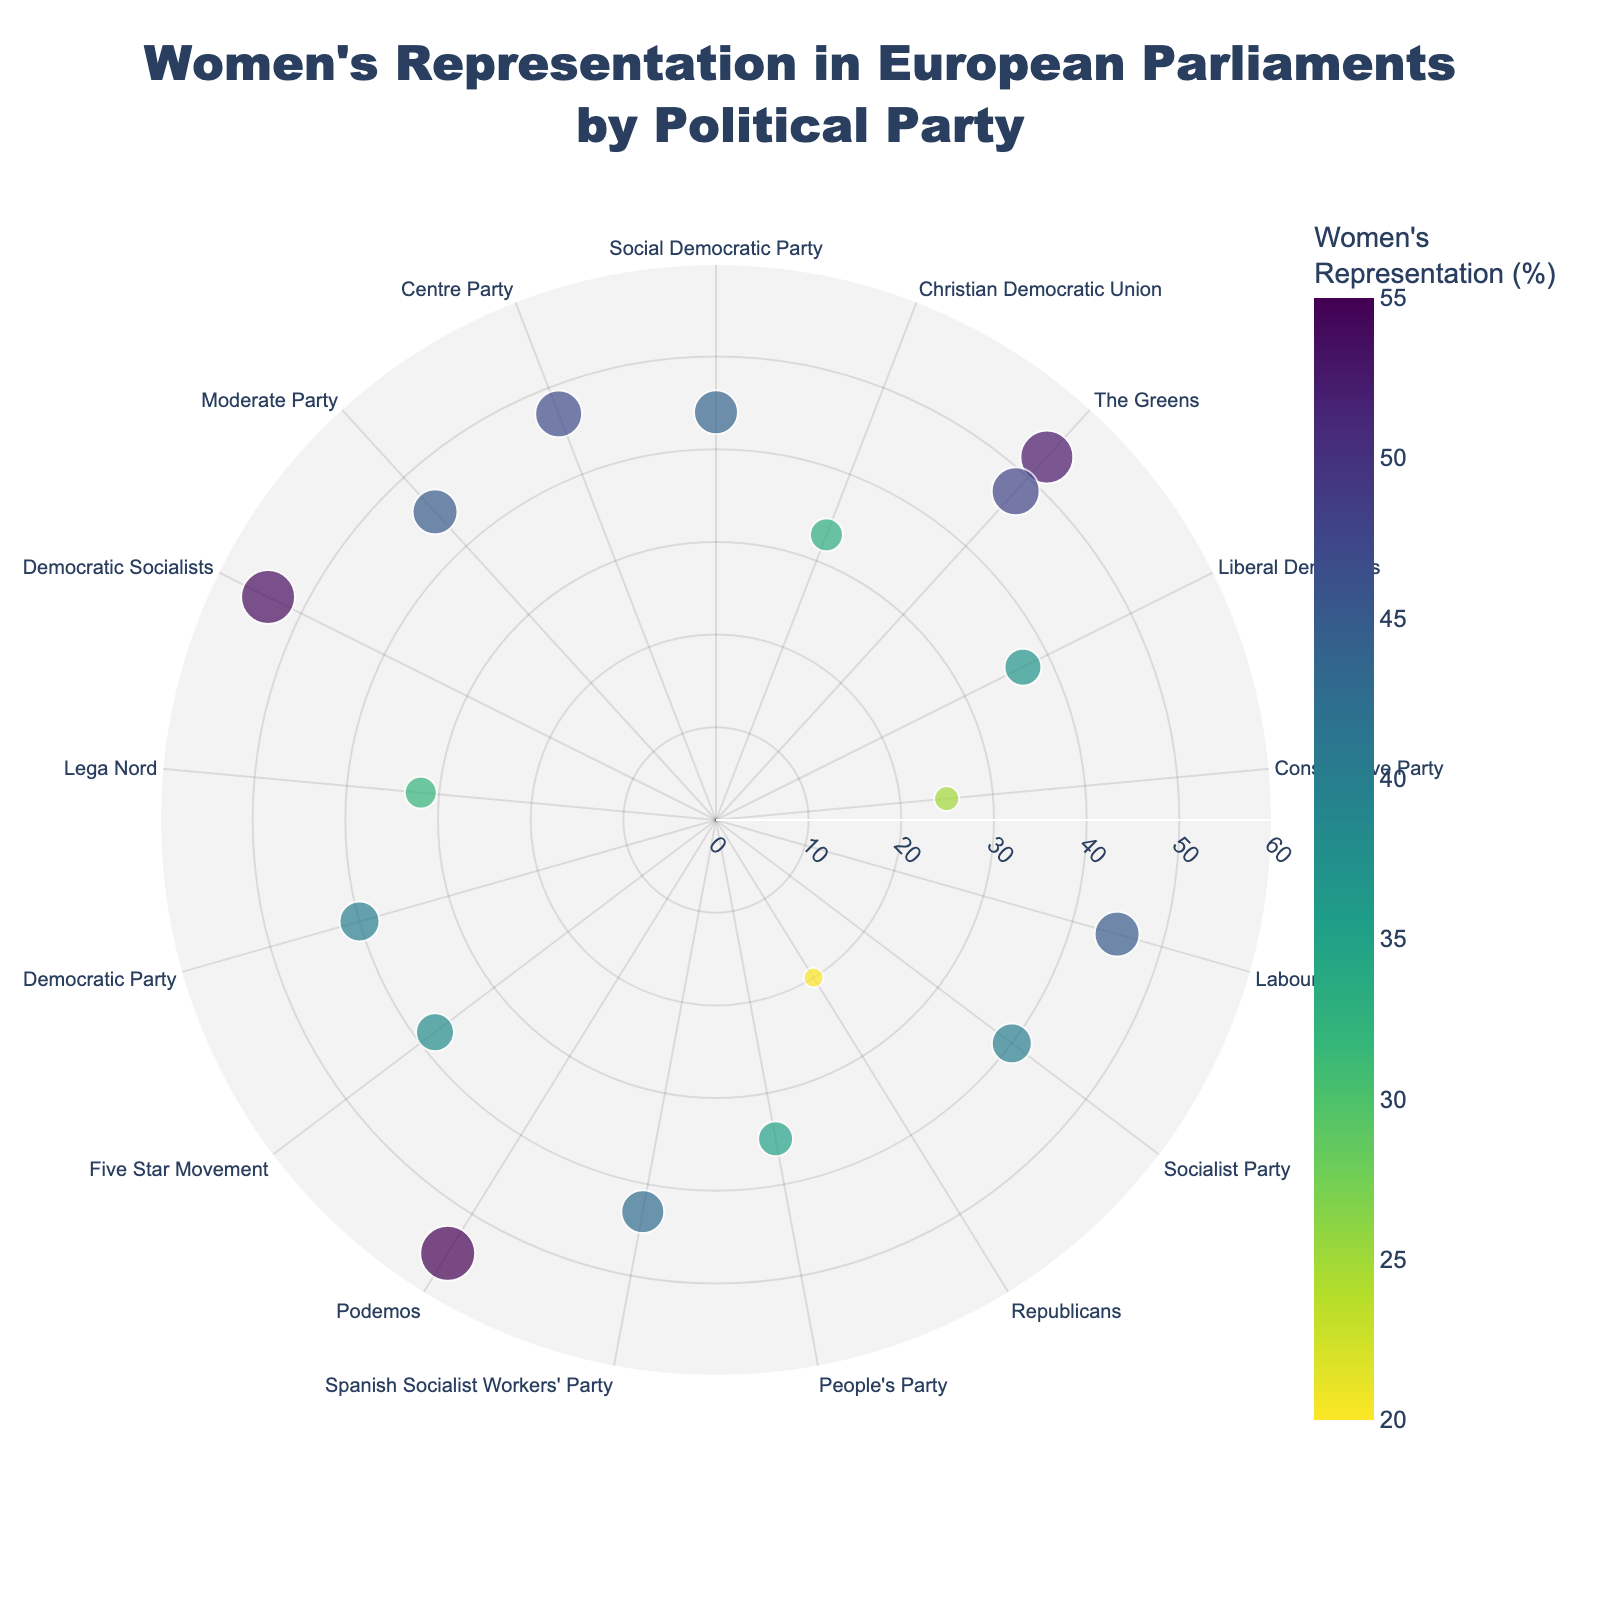What is the political party with the highest percentage of women's representation in Germany? The plot shows various political parties with labeled percentages for women's representation. By looking at the German parties, we see that The Greens have the highest value at 53%.
Answer: The Greens Which political party in the United Kingdom has the lowest percentage of women's representation? By examining the political parties from the United Kingdom on the plot, the Conservative Party shows the lowest percentage at 25%.
Answer: Conservative Party How does the women's representation in the Democratic Socialists (Sweden) compare to Lega Nord (Italy)? The plot indicates that the Democratic Socialists in Sweden have a percentage of 54% while Lega Nord in Italy has 32%. Therefore, the Democratic Socialists have a higher percentage of women's representation than Lega Nord.
Answer: Higher What is the approximate average percentage of women's representation among the political parties in France? The percentages for France are 48% (The Greens), 40% (Socialist Party), and 20% (Republicans). Summing these gives 108%, and dividing by the three parties, the average is approximately 36%.
Answer: 36% Which political party has a nearly equal percentage of women's representation to the Labour Party in the United Kingdom? The Labour Party in the United Kingdom has 45% women's representation. Checking other parties, the Moderate Party in Sweden also has 45%, making it roughly equal.
Answer: Moderate Party Which country has the highest average percentage of women's representation across its political parties? First, calculate each country's average:
  - Germany: (44+33+53)/3 = 43.33%
  - United Kingdom: (37+25+45)/3 = 35.67%
  - France: (48+40+20)/3 = 36%
  - Spain: (35+43+55)/3 = 44.33%
  - Italy: (38+40+32)/3 = 36.67%
  - Sweden: (54+45+47)/3 = 48.67%
  Sweden has the highest average with 48.67%.
Answer: Sweden Examine the radial distance in the polar chart. Which party lies closest to the outermost ring? The outermost ring corresponds to the highest values. The Podemos party in Spain, with 55% representation, is closest to the outermost ring.
Answer: Podemos How does the women's representation in the People's Party (Spain) compare to the Liberal Democrats (United Kingdom)? The People's Party in Spain has 35% representation, while the Liberal Democrats in the United Kingdom have 37%. The Liberal Democrats' representation is slightly higher.
Answer: Slightly higher In the context of the data shown, how many political parties have at least 50% women's representation? By looking at each political party, we find three that meet or exceed 50%: The Greens (Germany) with 53%, Podemos (Spain) with 55%, and Democratic Socialists (Sweden) with 54%.
Answer: 3 